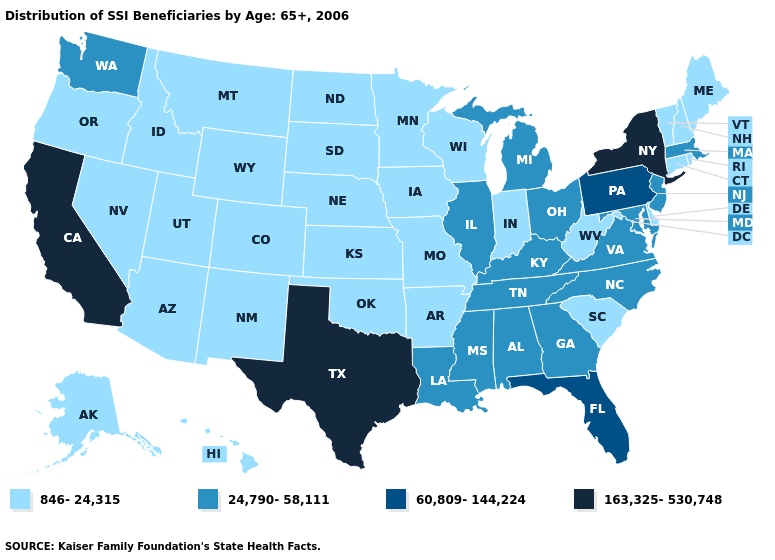Does Texas have the highest value in the USA?
Answer briefly. Yes. How many symbols are there in the legend?
Be succinct. 4. Name the states that have a value in the range 163,325-530,748?
Be succinct. California, New York, Texas. Name the states that have a value in the range 60,809-144,224?
Concise answer only. Florida, Pennsylvania. Does Illinois have the same value as Ohio?
Give a very brief answer. Yes. What is the value of North Carolina?
Quick response, please. 24,790-58,111. Does New Hampshire have a higher value than Wyoming?
Concise answer only. No. Among the states that border Indiana , which have the lowest value?
Keep it brief. Illinois, Kentucky, Michigan, Ohio. Name the states that have a value in the range 163,325-530,748?
Concise answer only. California, New York, Texas. What is the lowest value in states that border Vermont?
Write a very short answer. 846-24,315. Name the states that have a value in the range 846-24,315?
Keep it brief. Alaska, Arizona, Arkansas, Colorado, Connecticut, Delaware, Hawaii, Idaho, Indiana, Iowa, Kansas, Maine, Minnesota, Missouri, Montana, Nebraska, Nevada, New Hampshire, New Mexico, North Dakota, Oklahoma, Oregon, Rhode Island, South Carolina, South Dakota, Utah, Vermont, West Virginia, Wisconsin, Wyoming. How many symbols are there in the legend?
Be succinct. 4. Name the states that have a value in the range 163,325-530,748?
Concise answer only. California, New York, Texas. What is the lowest value in the USA?
Answer briefly. 846-24,315. What is the value of Oklahoma?
Short answer required. 846-24,315. 